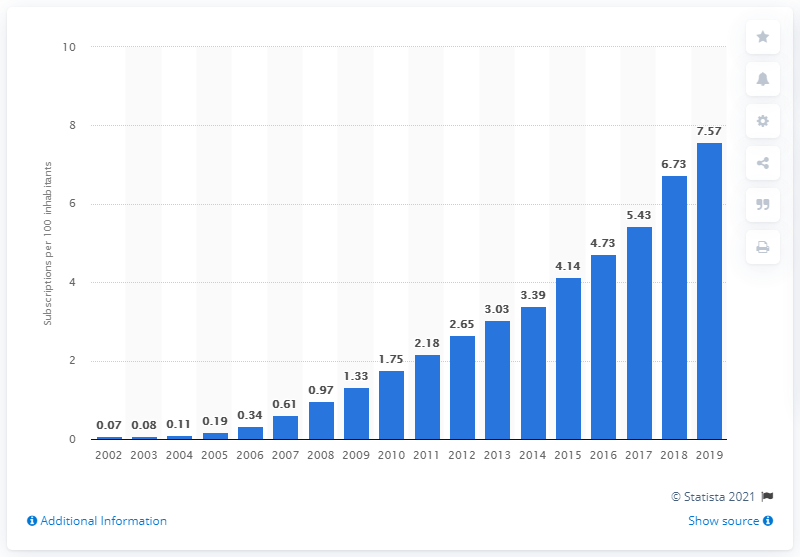List a handful of essential elements in this visual. In the year 2002, Egypt had its first fixed broadband subscription. In 2019, there were 7.57 fixed broadband subscriptions for every 100 inhabitants in Egypt. 